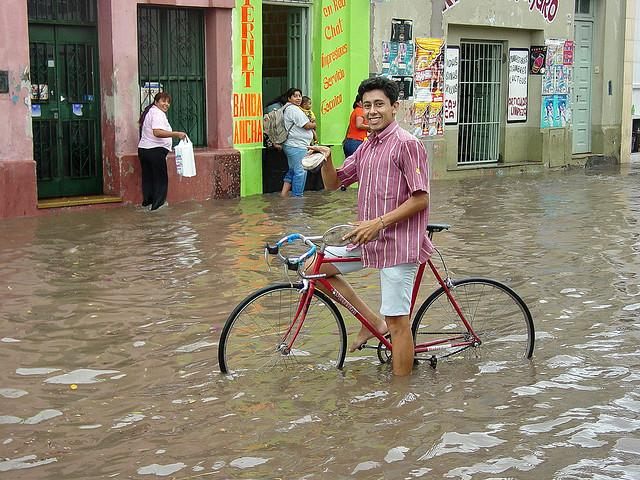Where is the man in?

Choices:
A) pool
B) street
C) yard
D) playground street 